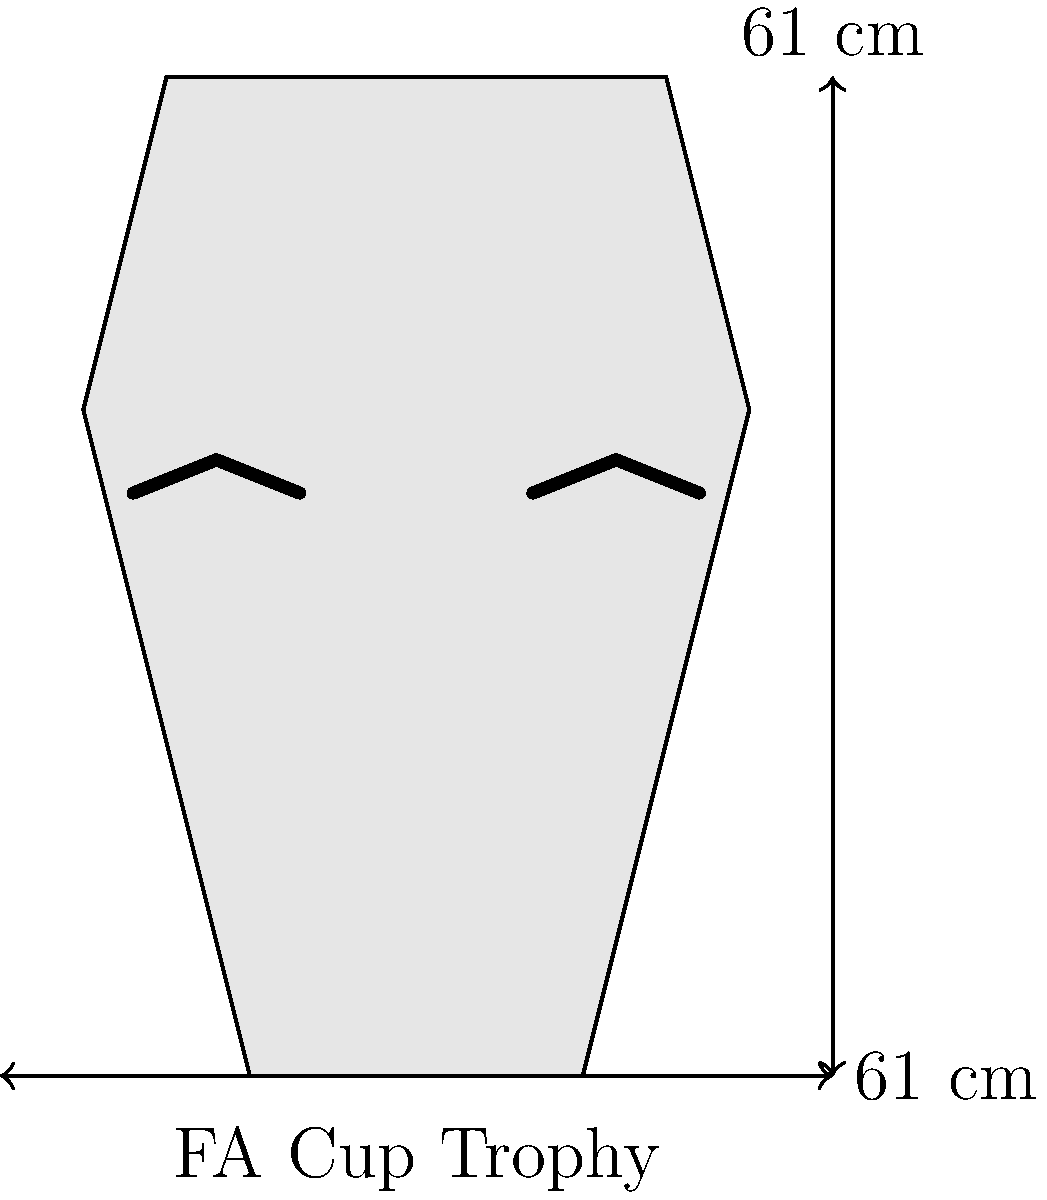In the iconic 1988 FA Cup victory, Wimbledon FC players proudly held the trophy aloft. Given that the FA Cup trophy is 61 cm tall and 61 cm wide at its widest point, what is the approximate area (in square centimeters) that a player's hands would cover when gripping the trophy at its midpoint, assuming their hands span 20 cm horizontally on each side? To solve this problem, let's follow these steps:

1. Understand the trophy's dimensions:
   - Height: 61 cm
   - Width at widest point: 61 cm

2. Locate the midpoint of the trophy:
   - Midpoint height = 61 cm ÷ 2 = 30.5 cm

3. Estimate the width of the trophy at the midpoint:
   - The trophy is roughly triangular in shape
   - At the midpoint, we can estimate the width to be about 2/3 of the maximum width
   - Estimated width at midpoint = 61 cm × (2/3) ≈ 40.67 cm

4. Calculate the span of the player's hands:
   - Given: 20 cm on each side
   - Total hand span = 20 cm × 2 = 40 cm

5. Calculate the area covered by the hands:
   - Area ≈ Hand span × Trophy width at midpoint
   - Area ≈ 40 cm × 40.67 cm
   - Area ≈ 1,626.8 cm²

Therefore, the approximate area covered by a player's hands when gripping the FA Cup trophy at its midpoint is about 1,627 square centimeters.
Answer: 1,627 cm² 